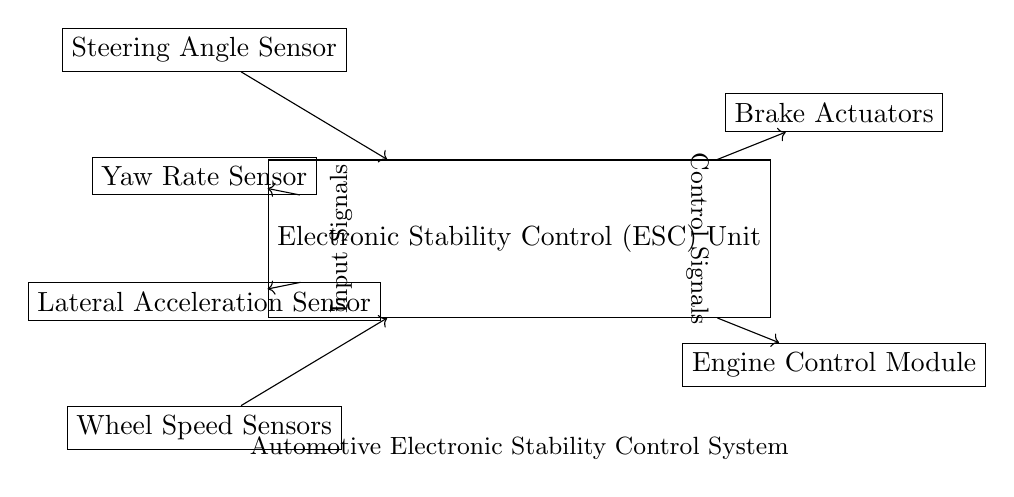What is the main component of the circuit? The main component is the Electronic Stability Control Unit, which manages input from various sensors and sends control signals to actuators.
Answer: Electronic Stability Control Unit How many types of sensors are connected to the controller? There are four types of sensors connected: Steering Angle Sensor, Yaw Rate Sensor, Lateral Acceleration Sensor, and Wheel Speed Sensors.
Answer: Four What type of outputs does the controller generate? The controller generates control signals that are sent to Brake Actuators and Engine Control Module.
Answer: Control signals Which sensors provide input to the stability control unit? The sensors providing input are the Steering Angle Sensor, Yaw Rate Sensor, Lateral Acceleration Sensor, and Wheel Speed Sensors.
Answer: Four sensors What components are categorized as actuators in this circuit? The actuators in the circuit are the Brake Actuators and the Engine Control Module.
Answer: Brake Actuators and Engine Control Module What kind of system does this circuit represent? This circuit represents an automotive electronic stability control system designed to enhance vehicle safety by improving stability.
Answer: Automotive electronic stability control system 